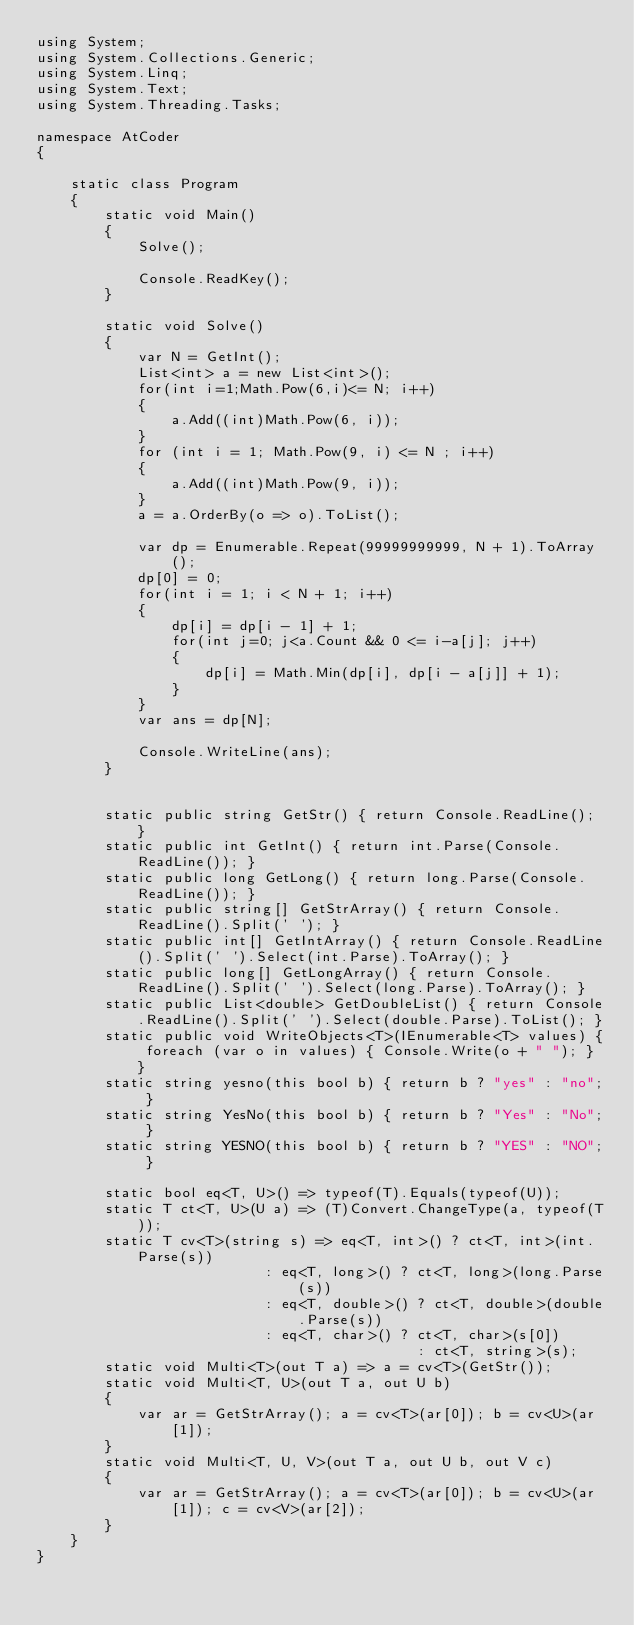Convert code to text. <code><loc_0><loc_0><loc_500><loc_500><_C#_>using System;
using System.Collections.Generic;
using System.Linq;
using System.Text;
using System.Threading.Tasks;

namespace AtCoder
{

    static class Program
    {
        static void Main()
        {
            Solve();

            Console.ReadKey();
        }

        static void Solve()
        {
            var N = GetInt();
            List<int> a = new List<int>();
            for(int i=1;Math.Pow(6,i)<= N; i++)
            {
                a.Add((int)Math.Pow(6, i));
            }
            for (int i = 1; Math.Pow(9, i) <= N ; i++)
            {
                a.Add((int)Math.Pow(9, i));
            }
            a = a.OrderBy(o => o).ToList();

            var dp = Enumerable.Repeat(99999999999, N + 1).ToArray();
            dp[0] = 0;
            for(int i = 1; i < N + 1; i++)
            {
                dp[i] = dp[i - 1] + 1;
                for(int j=0; j<a.Count && 0 <= i-a[j]; j++)
                {
                    dp[i] = Math.Min(dp[i], dp[i - a[j]] + 1);
                }
            }
            var ans = dp[N];

            Console.WriteLine(ans); 
        }


        static public string GetStr() { return Console.ReadLine(); }
        static public int GetInt() { return int.Parse(Console.ReadLine()); }
        static public long GetLong() { return long.Parse(Console.ReadLine()); }
        static public string[] GetStrArray() { return Console.ReadLine().Split(' '); }
        static public int[] GetIntArray() { return Console.ReadLine().Split(' ').Select(int.Parse).ToArray(); }
        static public long[] GetLongArray() { return Console.ReadLine().Split(' ').Select(long.Parse).ToArray(); }
        static public List<double> GetDoubleList() { return Console.ReadLine().Split(' ').Select(double.Parse).ToList(); }
        static public void WriteObjects<T>(IEnumerable<T> values) { foreach (var o in values) { Console.Write(o + " "); } }
        static string yesno(this bool b) { return b ? "yes" : "no"; }
        static string YesNo(this bool b) { return b ? "Yes" : "No"; }
        static string YESNO(this bool b) { return b ? "YES" : "NO"; }

        static bool eq<T, U>() => typeof(T).Equals(typeof(U));
        static T ct<T, U>(U a) => (T)Convert.ChangeType(a, typeof(T));
        static T cv<T>(string s) => eq<T, int>() ? ct<T, int>(int.Parse(s))
                           : eq<T, long>() ? ct<T, long>(long.Parse(s))
                           : eq<T, double>() ? ct<T, double>(double.Parse(s))
                           : eq<T, char>() ? ct<T, char>(s[0])
                                             : ct<T, string>(s);
        static void Multi<T>(out T a) => a = cv<T>(GetStr());
        static void Multi<T, U>(out T a, out U b)
        {
            var ar = GetStrArray(); a = cv<T>(ar[0]); b = cv<U>(ar[1]);
        }
        static void Multi<T, U, V>(out T a, out U b, out V c)
        {
            var ar = GetStrArray(); a = cv<T>(ar[0]); b = cv<U>(ar[1]); c = cv<V>(ar[2]);
        }
    }
}</code> 